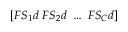<formula> <loc_0><loc_0><loc_500><loc_500>[ F S _ { 1 } d \ F S _ { 2 } d \ \dots \ F S _ { C } d ]</formula> 